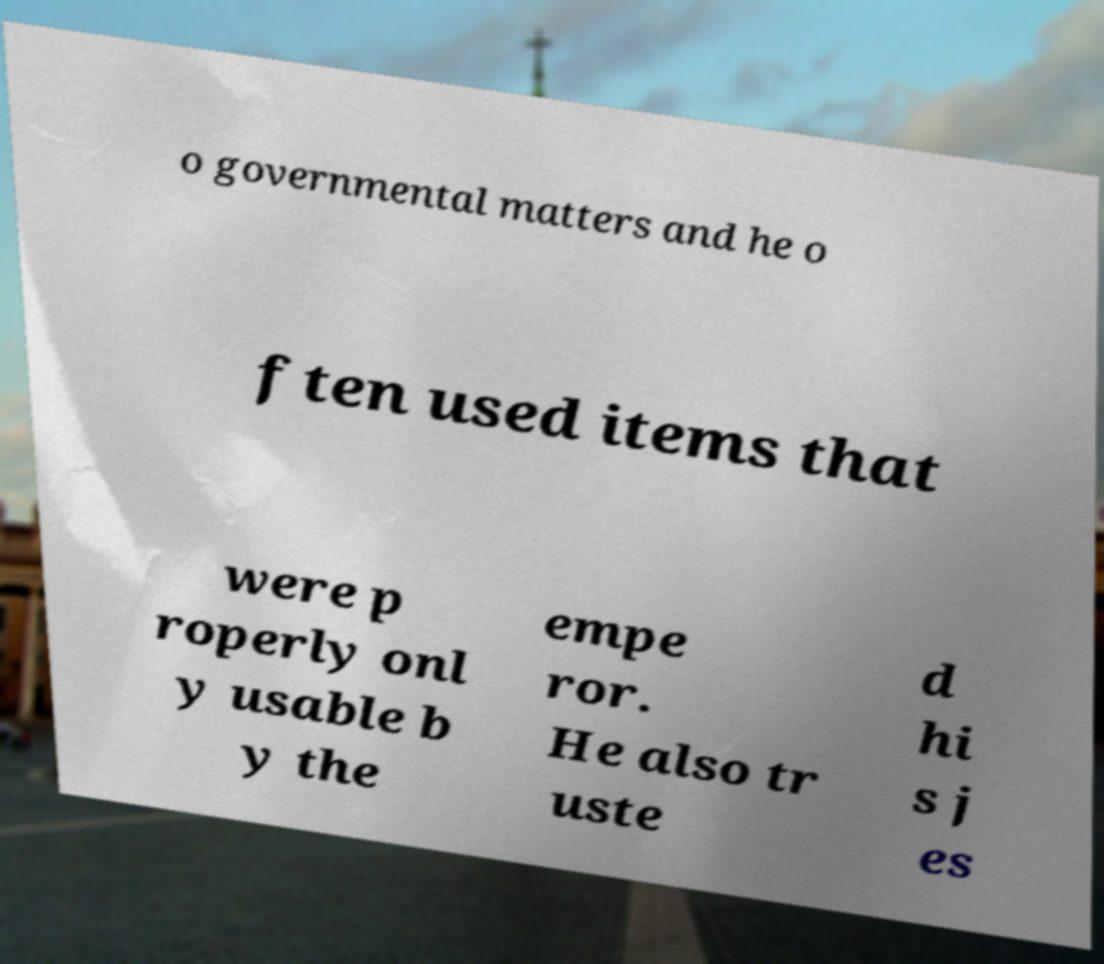There's text embedded in this image that I need extracted. Can you transcribe it verbatim? o governmental matters and he o ften used items that were p roperly onl y usable b y the empe ror. He also tr uste d hi s j es 